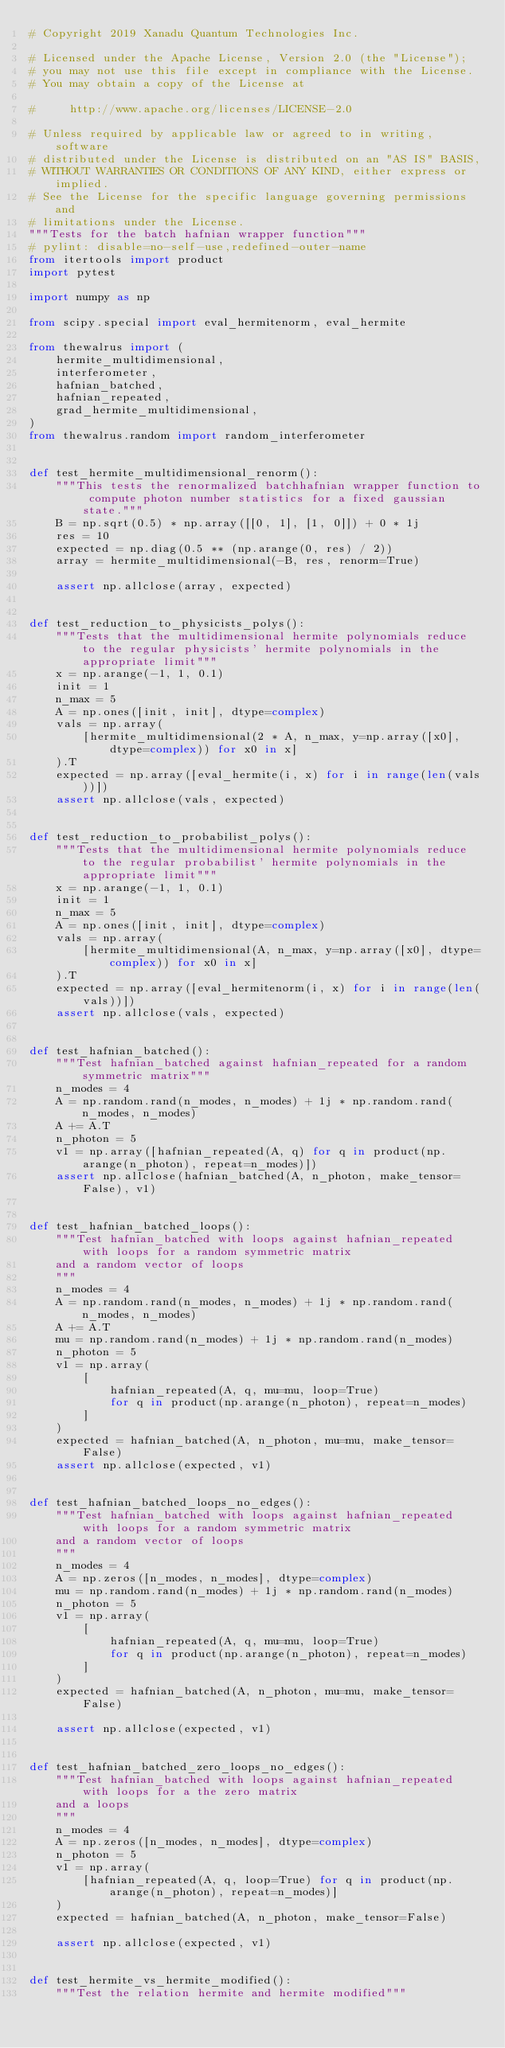<code> <loc_0><loc_0><loc_500><loc_500><_Python_># Copyright 2019 Xanadu Quantum Technologies Inc.

# Licensed under the Apache License, Version 2.0 (the "License");
# you may not use this file except in compliance with the License.
# You may obtain a copy of the License at

#     http://www.apache.org/licenses/LICENSE-2.0

# Unless required by applicable law or agreed to in writing, software
# distributed under the License is distributed on an "AS IS" BASIS,
# WITHOUT WARRANTIES OR CONDITIONS OF ANY KIND, either express or implied.
# See the License for the specific language governing permissions and
# limitations under the License.
"""Tests for the batch hafnian wrapper function"""
# pylint: disable=no-self-use,redefined-outer-name
from itertools import product
import pytest

import numpy as np

from scipy.special import eval_hermitenorm, eval_hermite

from thewalrus import (
    hermite_multidimensional,
    interferometer,
    hafnian_batched,
    hafnian_repeated,
    grad_hermite_multidimensional,
)
from thewalrus.random import random_interferometer


def test_hermite_multidimensional_renorm():
    """This tests the renormalized batchhafnian wrapper function to compute photon number statistics for a fixed gaussian state."""
    B = np.sqrt(0.5) * np.array([[0, 1], [1, 0]]) + 0 * 1j
    res = 10
    expected = np.diag(0.5 ** (np.arange(0, res) / 2))
    array = hermite_multidimensional(-B, res, renorm=True)

    assert np.allclose(array, expected)


def test_reduction_to_physicists_polys():
    """Tests that the multidimensional hermite polynomials reduce to the regular physicists' hermite polynomials in the appropriate limit"""
    x = np.arange(-1, 1, 0.1)
    init = 1
    n_max = 5
    A = np.ones([init, init], dtype=complex)
    vals = np.array(
        [hermite_multidimensional(2 * A, n_max, y=np.array([x0], dtype=complex)) for x0 in x]
    ).T
    expected = np.array([eval_hermite(i, x) for i in range(len(vals))])
    assert np.allclose(vals, expected)


def test_reduction_to_probabilist_polys():
    """Tests that the multidimensional hermite polynomials reduce to the regular probabilist' hermite polynomials in the appropriate limit"""
    x = np.arange(-1, 1, 0.1)
    init = 1
    n_max = 5
    A = np.ones([init, init], dtype=complex)
    vals = np.array(
        [hermite_multidimensional(A, n_max, y=np.array([x0], dtype=complex)) for x0 in x]
    ).T
    expected = np.array([eval_hermitenorm(i, x) for i in range(len(vals))])
    assert np.allclose(vals, expected)


def test_hafnian_batched():
    """Test hafnian_batched against hafnian_repeated for a random symmetric matrix"""
    n_modes = 4
    A = np.random.rand(n_modes, n_modes) + 1j * np.random.rand(n_modes, n_modes)
    A += A.T
    n_photon = 5
    v1 = np.array([hafnian_repeated(A, q) for q in product(np.arange(n_photon), repeat=n_modes)])
    assert np.allclose(hafnian_batched(A, n_photon, make_tensor=False), v1)


def test_hafnian_batched_loops():
    """Test hafnian_batched with loops against hafnian_repeated with loops for a random symmetric matrix
    and a random vector of loops
    """
    n_modes = 4
    A = np.random.rand(n_modes, n_modes) + 1j * np.random.rand(n_modes, n_modes)
    A += A.T
    mu = np.random.rand(n_modes) + 1j * np.random.rand(n_modes)
    n_photon = 5
    v1 = np.array(
        [
            hafnian_repeated(A, q, mu=mu, loop=True)
            for q in product(np.arange(n_photon), repeat=n_modes)
        ]
    )
    expected = hafnian_batched(A, n_photon, mu=mu, make_tensor=False)
    assert np.allclose(expected, v1)


def test_hafnian_batched_loops_no_edges():
    """Test hafnian_batched with loops against hafnian_repeated with loops for a random symmetric matrix
    and a random vector of loops
    """
    n_modes = 4
    A = np.zeros([n_modes, n_modes], dtype=complex)
    mu = np.random.rand(n_modes) + 1j * np.random.rand(n_modes)
    n_photon = 5
    v1 = np.array(
        [
            hafnian_repeated(A, q, mu=mu, loop=True)
            for q in product(np.arange(n_photon), repeat=n_modes)
        ]
    )
    expected = hafnian_batched(A, n_photon, mu=mu, make_tensor=False)

    assert np.allclose(expected, v1)


def test_hafnian_batched_zero_loops_no_edges():
    """Test hafnian_batched with loops against hafnian_repeated with loops for a the zero matrix
    and a loops
    """
    n_modes = 4
    A = np.zeros([n_modes, n_modes], dtype=complex)
    n_photon = 5
    v1 = np.array(
        [hafnian_repeated(A, q, loop=True) for q in product(np.arange(n_photon), repeat=n_modes)]
    )
    expected = hafnian_batched(A, n_photon, make_tensor=False)

    assert np.allclose(expected, v1)


def test_hermite_vs_hermite_modified():
    """Test the relation hermite and hermite modified"""</code> 